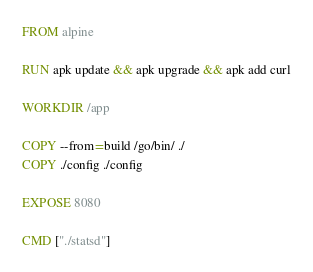<code> <loc_0><loc_0><loc_500><loc_500><_Dockerfile_>
FROM alpine

RUN apk update && apk upgrade && apk add curl

WORKDIR /app

COPY --from=build /go/bin/ ./
COPY ./config ./config

EXPOSE 8080

CMD ["./statsd"]
</code> 